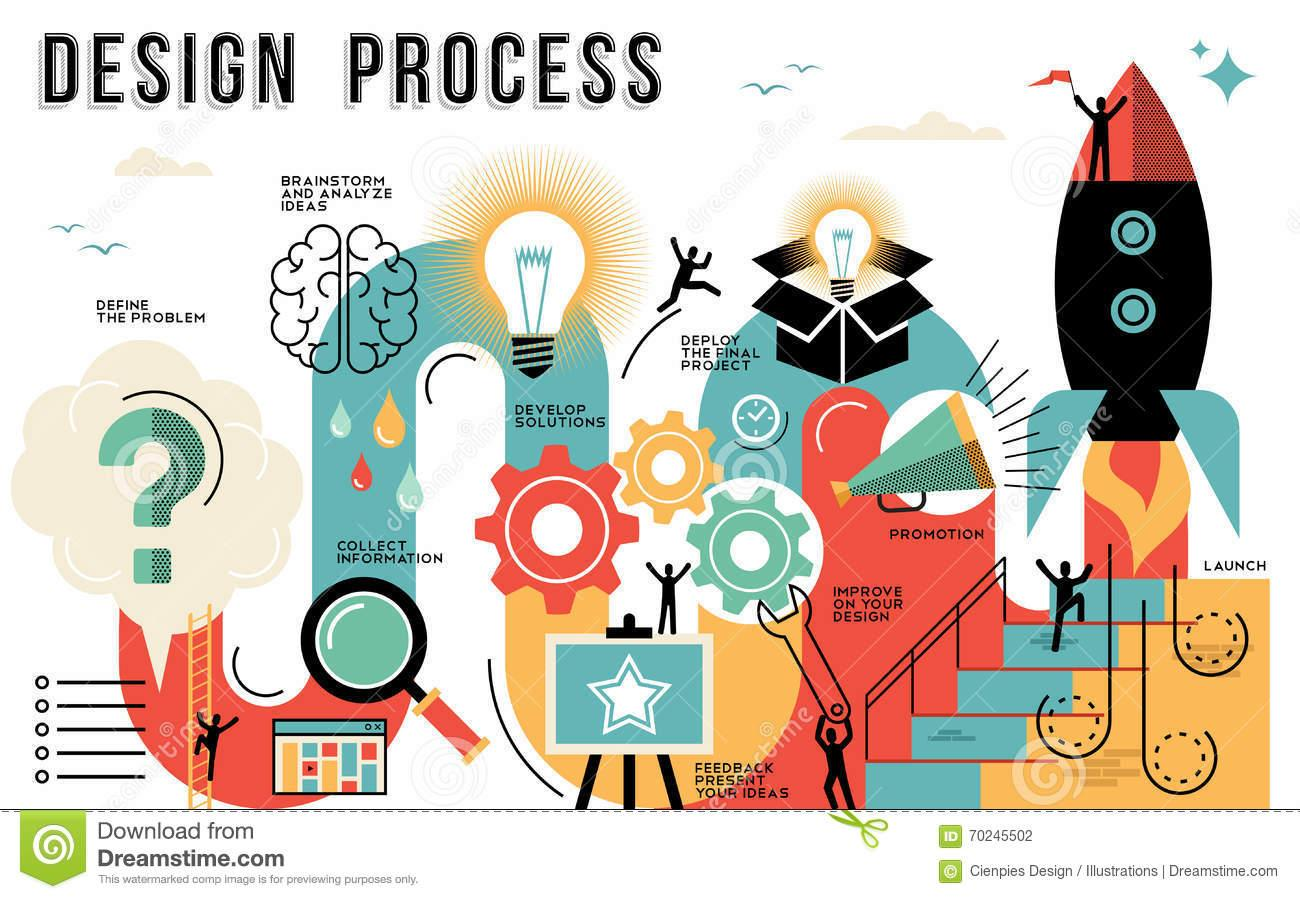Identify some key points in this picture. The speaker in the given sentence is demonstrating the process of promotion. The notice board displays either a star or a moon, and it is clearly visible that it is a star. The process implied by a magnifying lens is the collection of information by enlarging the size of an object or image. The question mark implies the process of defining the problem. The process of brainstorming and analyzing ideas is defined by the brain. 